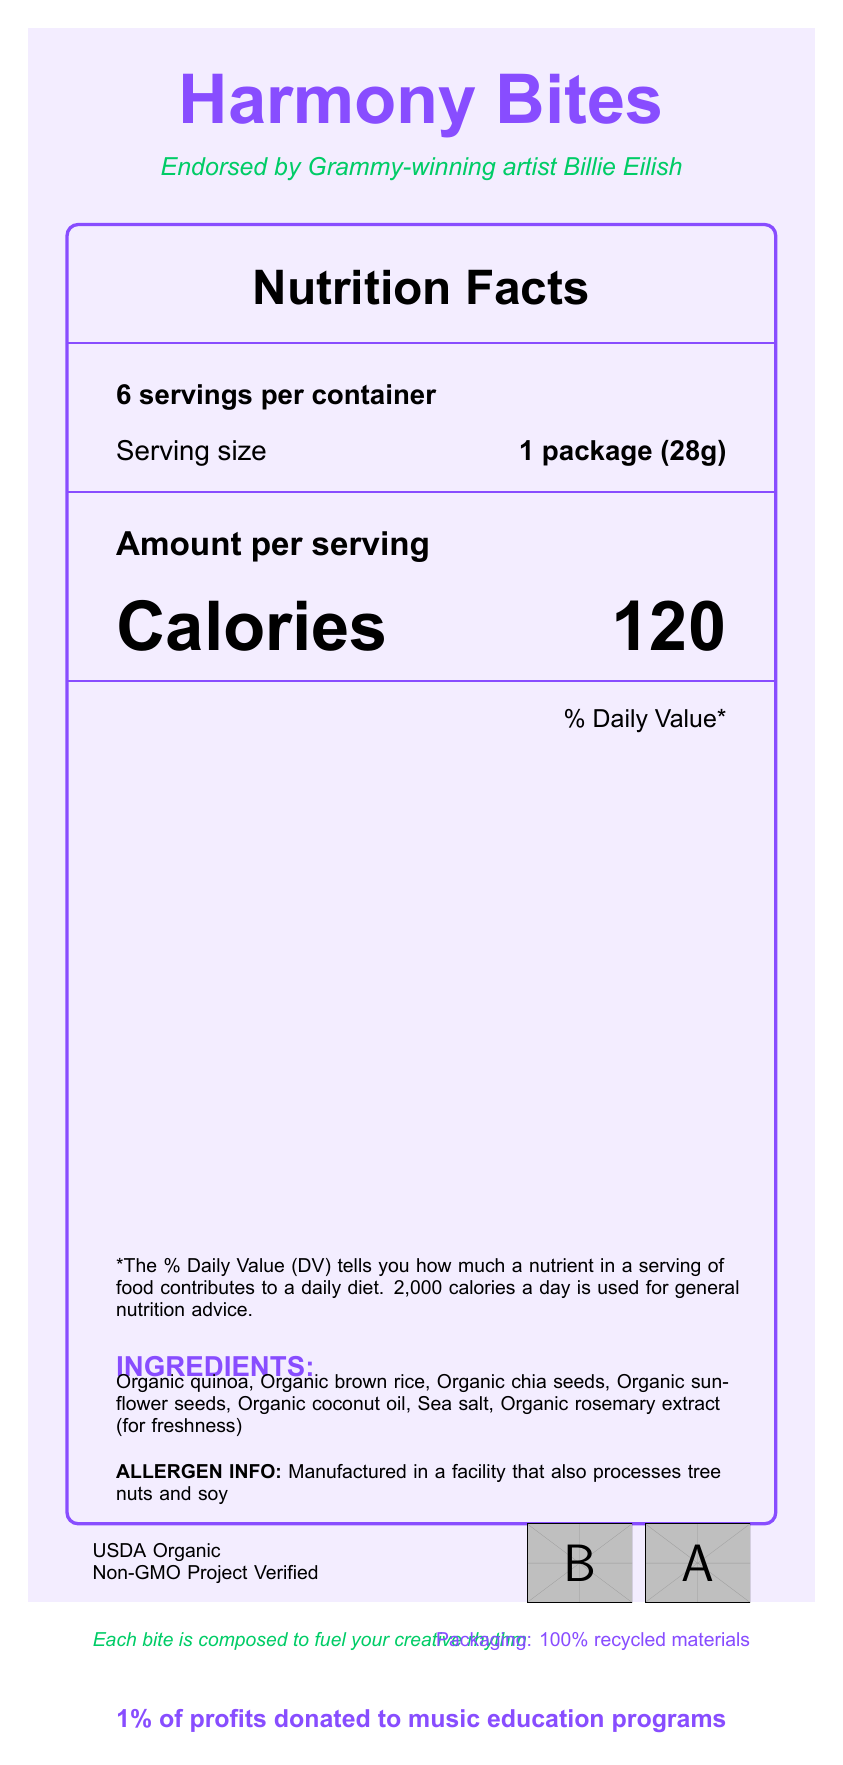what is the serving size? The serving size is explicitly mentioned as "1 package (28g)" in the document.
Answer: 1 package (28g) how many calories are in one serving of Harmony Bites? The document shows "Calories 120" under the Amount per serving section.
Answer: 120 what is the total fat content per serving in grams? The document lists "Total Fat" as 6g in the nutrition facts section.
Answer: 6g what ingredients are used in Harmony Bites? These are the ingredients listed under the "INGREDIENTS" section.
Answer: Organic quinoa, Organic brown rice, Organic chia seeds, Organic sunflower seeds, Organic coconut oil, Sea salt, Organic rosemary extract (for freshness) how much protein does each serving contain? The document shows "Protein 3g" in the nutrition facts section.
Answer: 3g who endorsed the Harmony Bites product? A. Taylor Swift B. Billie Eilish C. Ed Sheeran D. Adele The document states that the product is "Endorsed by Grammy-winning artist Billie Eilish."
Answer: B what is the daily value percentage of dietary fiber per serving? i. 2% ii. 4% iii. 7% iv. 10% The document lists "Dietary Fiber 2g" with a daily value of "7%" in the nutrition facts section.
Answer: iii. 7% is vitamin D present in Harmony Bites? The document states that Vitamin D is 0mcg with a daily value of 0%.
Answer: No does the packaging claim to be made from recycled materials? The document mentions "Packaging: 100% recycled materials" in the sustainability section.
Answer: Yes summarize the main features of the Harmony Bites product. This summary includes the essential points: endorsement by Billie Eilish, key nutrition facts, organic certification, ingredients, sustainability claim, and social impact.
Answer: Harmony Bites are organic snacks endorsed by Billie Eilish. The product's nutrition facts include 120 calories per serving, with a notable highlight on being USDA Organic and Non-GMO Project Verified. The ingredients are entirely organic, and the packaging is made from recycled materials. The product also supports music education programs by donating 1% of its profits. what percentage of daily value is contributed by iron per serving? The document lists "Iron 0.7mg" with a daily value percentage of 4%.
Answer: 4% how many added sugars are there per serving? The document states that there are "Includes 1g Added Sugars" under the "Total Sugars" section.
Answer: 1g are there any allergens mentioned in the document? The document mentions that the product is "Manufactured in a facility that also processes tree nuts and soy."
Answer: Yes what is the recommended daily calorie intake mentioned in the document? The document states that "2,000 calories a day is used for general nutrition advice" in the footnote.
Answer: 2,000 calories how many servings are there per container of Harmony Bites? The document indicates "6 servings per container" at the top of the nutrition facts section.
Answer: 6 what is the percentage of daily value for sodium per serving? The document shows "Sodium 140mg" with a daily value of 6%.
Answer: 6% which claim is not mentioned on the product packaging? (a) USDA Organic (b) Non-GMO Project Verified (c) Gluten-Free (d) 100% recycled materials The document mentions USDA Organic, Non-GMO Project Verified, and 100% recycled materials but does not mention Gluten-Free.
Answer: (c) Gluten-Free how is the product described in relation to music? The document contains the phrase "Each bite is composed to fuel your creative rhythm" under the musical note and sustainability section.
Answer: Each bite is composed to fuel your creative rhythm what is the product's name? The product name is displayed prominently at the top of the document.
Answer: Harmony Bites what certification ensures the organic standard of the product? The document shows that the product is certified as "USDA Organic."
Answer: USDA Organic what is the total carbohydrate content per serving? The document lists "Total Carbohydrate 15g" under the nutrition facts section.
Answer: 15g does the product contain cholesterol? The document shows "Cholesterol 0mg" with a daily value of 0%.
Answer: No which art style is used for the document's design? The style details are not provided in the document; we only have the nutrition information and related product details.
Answer: Cannot be determined 